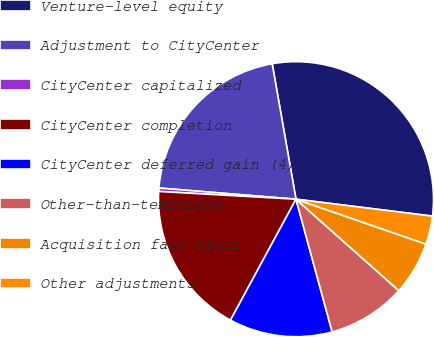Convert chart to OTSL. <chart><loc_0><loc_0><loc_500><loc_500><pie_chart><fcel>Venture-level equity<fcel>Adjustment to CityCenter<fcel>CityCenter capitalized<fcel>CityCenter completion<fcel>CityCenter deferred gain (4)<fcel>Other-than-temporary<fcel>Acquisition fair value<fcel>Other adjustments<nl><fcel>29.73%<fcel>20.93%<fcel>0.4%<fcel>18.0%<fcel>12.13%<fcel>9.2%<fcel>6.27%<fcel>3.33%<nl></chart> 